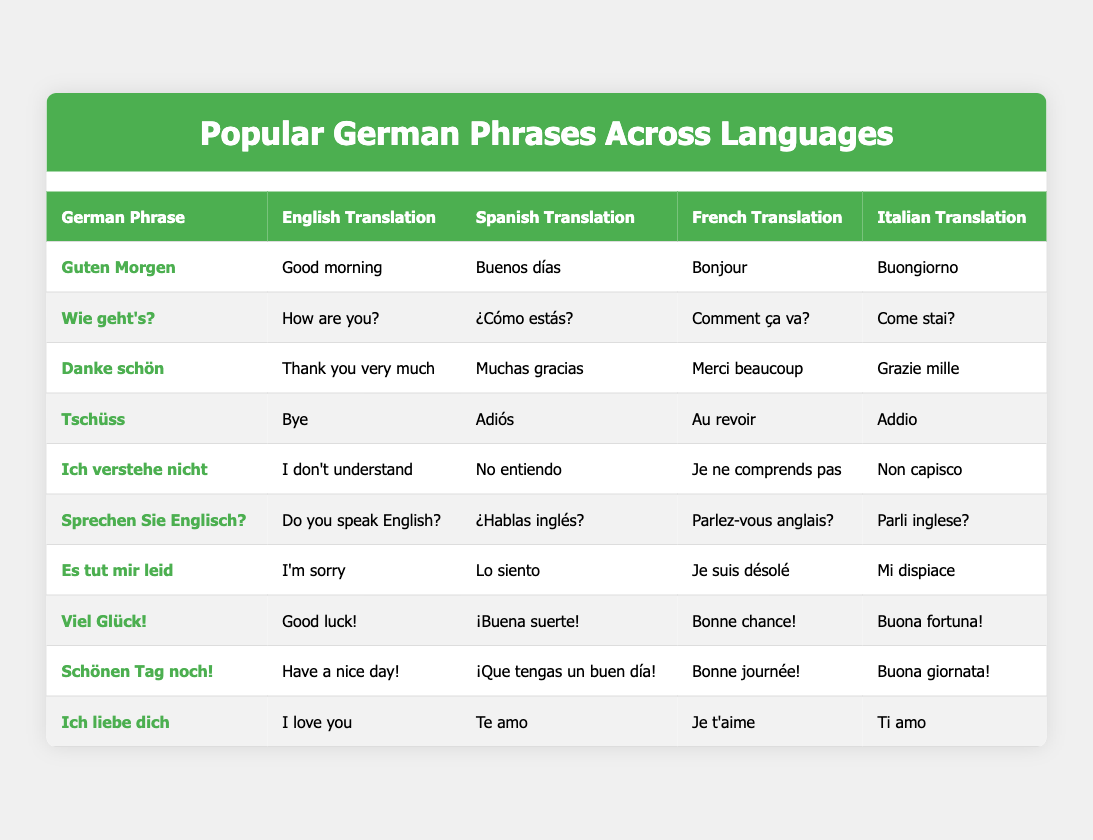What is the Spanish translation for "Danke schön"? The table shows that the German phrase "Danke schön" is translated to Spanish as "Muchas gracias."
Answer: Muchas gracias How do you say "Good morning" in French? According to the table, "Guten Morgen" translates to "Bonjour" in French.
Answer: Bonjour Is "Ich liebe dich" translated as "I love you" in English? Yes, the table confirms that the German phrase "Ich liebe dich" translates to "I love you" in English.
Answer: Yes What is the English translation of "Tschüss"? The table indicates that "Tschüss" translates to "Bye" in English.
Answer: Bye Which phrase in German means "I don't understand"? The table shows that "Ich verstehe nicht" means "I don’t understand."
Answer: Ich verstehe nicht Are there any phrases in the table that translate to "Good luck" in different languages? Yes, "Viel Glück!" is translated to "Good luck!" in English, "¡Buena suerte!" in Spanish, "Bonne chance!" in French, and "Buona fortuna!" in Italian.
Answer: Yes What are the languages into which "Es tut mir leid" is translated? The table illustrates that "Es tut mir leid" is translated into English ("I'm sorry"), Spanish ("Lo siento"), French ("Je suis désolé"), and Italian ("Mi dispiace").
Answer: English, Spanish, French, Italian What is the Italian translation of "Have a nice day!"? According to the table, "Schönen Tag noch!" translates to "Buona giornata!" in Italian.
Answer: Buona giornata! Is "Wie geht's?" the German phrase for "How are you?" in English? Yes, "Wie geht's?" is translated to "How are you?" in English, as indicated in the table.
Answer: Yes What is the average number of translations provided per German phrase in the table? There are 10 German phrases, each with 4 translations. Therefore, the average is 4 translations per phrase (4 translations * 10 phrases = 40 translations, then 40/10 = 4).
Answer: 4 What is the relationship between the phrases "Ich verstehe nicht" and "Sprechen Sie Englisch?" in terms of context? Both phrases deal with communication in a foreign language, where "Ich verstehe nicht" indicates a lack of understanding, and "Sprechen Sie Englisch?" asks if the person speaks English, potentially offering a solution to the understanding issue.
Answer: Communication context What phrases share a similar emotional tone related to remorse or apologies? The phrases "Es tut mir leid" and "Danke schön" both express sentiments; the former conveys an apology while the latter expresses gratitude, showing different forms of politeness in interaction.
Answer: Apologies and gratitude How many phrases have translations that include the word "Hello" or its equivalents in other languages? From the table, none of the phrases include "Hello" or its equivalents in English, Spanish, French, or Italian; therefore, the count is zero.
Answer: Zero 